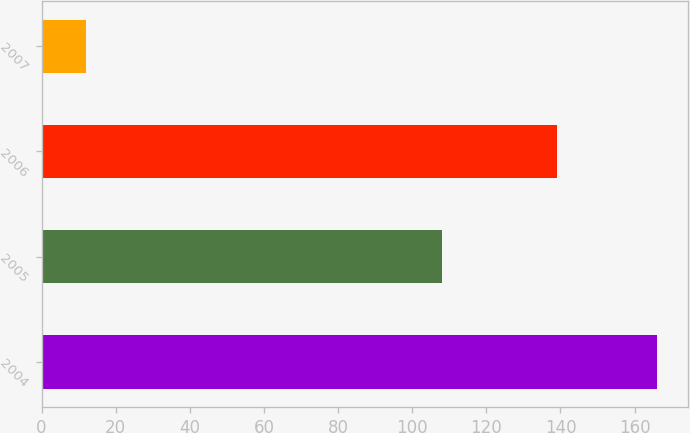Convert chart to OTSL. <chart><loc_0><loc_0><loc_500><loc_500><bar_chart><fcel>2004<fcel>2005<fcel>2006<fcel>2007<nl><fcel>166<fcel>108<fcel>139<fcel>12<nl></chart> 